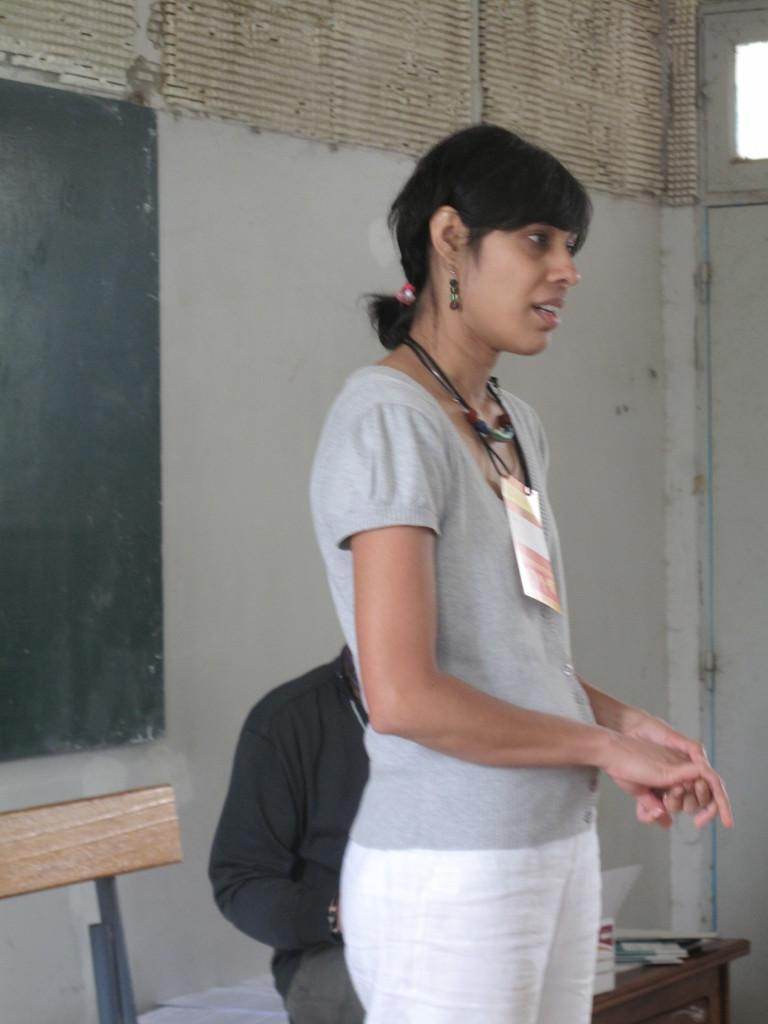What is happening in the image? There is a person standing in the image, and the person is talking. What can be seen behind the person? There is a wall behind the person. What type of ring is the person wearing on their foot in the image? There is no ring visible on the person's foot in the image, nor is there any indication that the person has a foot in the image. 